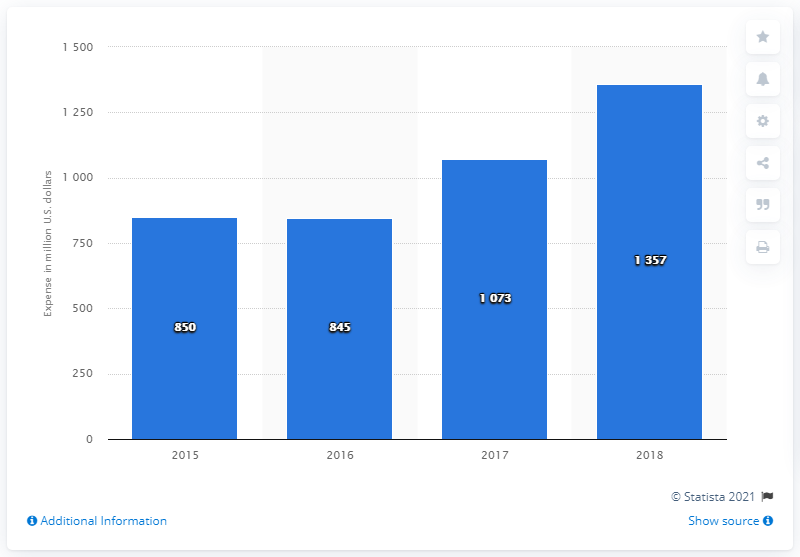List a handful of essential elements in this visual. In the year 2016, a staggering amount of 845 million U.S dollars was generated. The difference between the highest and lowest values is 512. 